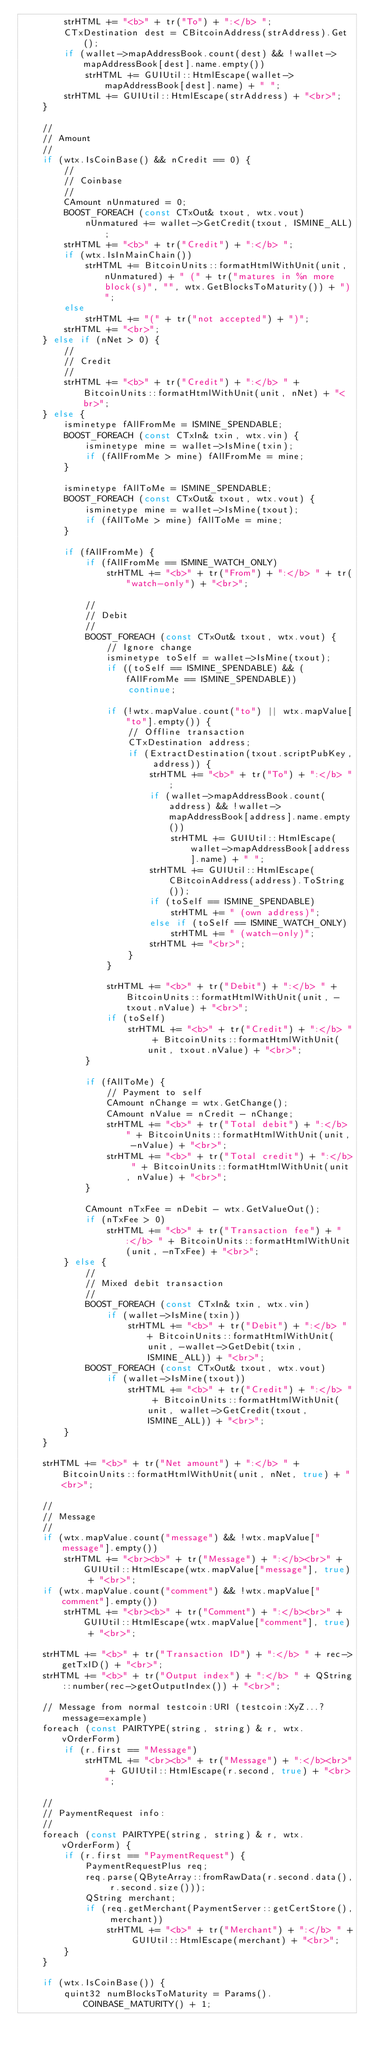<code> <loc_0><loc_0><loc_500><loc_500><_C++_>        strHTML += "<b>" + tr("To") + ":</b> ";
        CTxDestination dest = CBitcoinAddress(strAddress).Get();
        if (wallet->mapAddressBook.count(dest) && !wallet->mapAddressBook[dest].name.empty())
            strHTML += GUIUtil::HtmlEscape(wallet->mapAddressBook[dest].name) + " ";
        strHTML += GUIUtil::HtmlEscape(strAddress) + "<br>";
    }

    //
    // Amount
    //
    if (wtx.IsCoinBase() && nCredit == 0) {
        //
        // Coinbase
        //
        CAmount nUnmatured = 0;
        BOOST_FOREACH (const CTxOut& txout, wtx.vout)
            nUnmatured += wallet->GetCredit(txout, ISMINE_ALL);
        strHTML += "<b>" + tr("Credit") + ":</b> ";
        if (wtx.IsInMainChain())
            strHTML += BitcoinUnits::formatHtmlWithUnit(unit, nUnmatured) + " (" + tr("matures in %n more block(s)", "", wtx.GetBlocksToMaturity()) + ")";
        else
            strHTML += "(" + tr("not accepted") + ")";
        strHTML += "<br>";
    } else if (nNet > 0) {
        //
        // Credit
        //
        strHTML += "<b>" + tr("Credit") + ":</b> " + BitcoinUnits::formatHtmlWithUnit(unit, nNet) + "<br>";
    } else {
        isminetype fAllFromMe = ISMINE_SPENDABLE;
        BOOST_FOREACH (const CTxIn& txin, wtx.vin) {
            isminetype mine = wallet->IsMine(txin);
            if (fAllFromMe > mine) fAllFromMe = mine;
        }

        isminetype fAllToMe = ISMINE_SPENDABLE;
        BOOST_FOREACH (const CTxOut& txout, wtx.vout) {
            isminetype mine = wallet->IsMine(txout);
            if (fAllToMe > mine) fAllToMe = mine;
        }

        if (fAllFromMe) {
            if (fAllFromMe == ISMINE_WATCH_ONLY)
                strHTML += "<b>" + tr("From") + ":</b> " + tr("watch-only") + "<br>";

            //
            // Debit
            //
            BOOST_FOREACH (const CTxOut& txout, wtx.vout) {
                // Ignore change
                isminetype toSelf = wallet->IsMine(txout);
                if ((toSelf == ISMINE_SPENDABLE) && (fAllFromMe == ISMINE_SPENDABLE))
                    continue;

                if (!wtx.mapValue.count("to") || wtx.mapValue["to"].empty()) {
                    // Offline transaction
                    CTxDestination address;
                    if (ExtractDestination(txout.scriptPubKey, address)) {
                        strHTML += "<b>" + tr("To") + ":</b> ";
                        if (wallet->mapAddressBook.count(address) && !wallet->mapAddressBook[address].name.empty())
                            strHTML += GUIUtil::HtmlEscape(wallet->mapAddressBook[address].name) + " ";
                        strHTML += GUIUtil::HtmlEscape(CBitcoinAddress(address).ToString());
                        if (toSelf == ISMINE_SPENDABLE)
                            strHTML += " (own address)";
                        else if (toSelf == ISMINE_WATCH_ONLY)
                            strHTML += " (watch-only)";
                        strHTML += "<br>";
                    }
                }

                strHTML += "<b>" + tr("Debit") + ":</b> " + BitcoinUnits::formatHtmlWithUnit(unit, -txout.nValue) + "<br>";
                if (toSelf)
                    strHTML += "<b>" + tr("Credit") + ":</b> " + BitcoinUnits::formatHtmlWithUnit(unit, txout.nValue) + "<br>";
            }

            if (fAllToMe) {
                // Payment to self
                CAmount nChange = wtx.GetChange();
                CAmount nValue = nCredit - nChange;
                strHTML += "<b>" + tr("Total debit") + ":</b> " + BitcoinUnits::formatHtmlWithUnit(unit, -nValue) + "<br>";
                strHTML += "<b>" + tr("Total credit") + ":</b> " + BitcoinUnits::formatHtmlWithUnit(unit, nValue) + "<br>";
            }

            CAmount nTxFee = nDebit - wtx.GetValueOut();
            if (nTxFee > 0)
                strHTML += "<b>" + tr("Transaction fee") + ":</b> " + BitcoinUnits::formatHtmlWithUnit(unit, -nTxFee) + "<br>";
        } else {
            //
            // Mixed debit transaction
            //
            BOOST_FOREACH (const CTxIn& txin, wtx.vin)
                if (wallet->IsMine(txin))
                    strHTML += "<b>" + tr("Debit") + ":</b> " + BitcoinUnits::formatHtmlWithUnit(unit, -wallet->GetDebit(txin, ISMINE_ALL)) + "<br>";
            BOOST_FOREACH (const CTxOut& txout, wtx.vout)
                if (wallet->IsMine(txout))
                    strHTML += "<b>" + tr("Credit") + ":</b> " + BitcoinUnits::formatHtmlWithUnit(unit, wallet->GetCredit(txout, ISMINE_ALL)) + "<br>";
        }
    }

    strHTML += "<b>" + tr("Net amount") + ":</b> " + BitcoinUnits::formatHtmlWithUnit(unit, nNet, true) + "<br>";

    //
    // Message
    //
    if (wtx.mapValue.count("message") && !wtx.mapValue["message"].empty())
        strHTML += "<br><b>" + tr("Message") + ":</b><br>" + GUIUtil::HtmlEscape(wtx.mapValue["message"], true) + "<br>";
    if (wtx.mapValue.count("comment") && !wtx.mapValue["comment"].empty())
        strHTML += "<br><b>" + tr("Comment") + ":</b><br>" + GUIUtil::HtmlEscape(wtx.mapValue["comment"], true) + "<br>";

    strHTML += "<b>" + tr("Transaction ID") + ":</b> " + rec->getTxID() + "<br>";
    strHTML += "<b>" + tr("Output index") + ":</b> " + QString::number(rec->getOutputIndex()) + "<br>";

    // Message from normal testcoin:URI (testcoin:XyZ...?message=example)
    foreach (const PAIRTYPE(string, string) & r, wtx.vOrderForm)
        if (r.first == "Message")
            strHTML += "<br><b>" + tr("Message") + ":</b><br>" + GUIUtil::HtmlEscape(r.second, true) + "<br>";

    //
    // PaymentRequest info:
    //
    foreach (const PAIRTYPE(string, string) & r, wtx.vOrderForm) {
        if (r.first == "PaymentRequest") {
            PaymentRequestPlus req;
            req.parse(QByteArray::fromRawData(r.second.data(), r.second.size()));
            QString merchant;
            if (req.getMerchant(PaymentServer::getCertStore(), merchant))
                strHTML += "<b>" + tr("Merchant") + ":</b> " + GUIUtil::HtmlEscape(merchant) + "<br>";
        }
    }

    if (wtx.IsCoinBase()) {
        quint32 numBlocksToMaturity = Params().COINBASE_MATURITY() + 1;</code> 